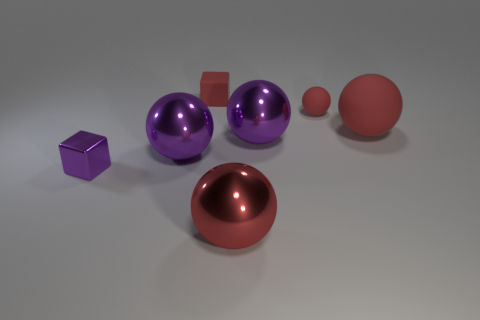There is a red thing that is the same shape as the small purple thing; what is its size?
Your answer should be very brief. Small. Do the red sphere that is in front of the large rubber sphere and the tiny block in front of the large red rubber thing have the same material?
Ensure brevity in your answer.  Yes. Is the number of large balls that are left of the metallic cube less than the number of big red balls?
Provide a short and direct response. Yes. Are there any other things that are the same shape as the tiny metal thing?
Offer a terse response. Yes. There is a matte thing that is the same shape as the tiny purple metallic object; what is its color?
Offer a terse response. Red. There is a purple sphere on the right side of the red shiny ball; is it the same size as the small metallic thing?
Make the answer very short. No. There is a purple ball on the left side of the purple object that is on the right side of the red block; what size is it?
Provide a short and direct response. Large. Is the tiny sphere made of the same material as the big ball on the left side of the red metal object?
Offer a terse response. No. Is the number of large red matte spheres that are in front of the small purple block less than the number of large purple things that are behind the red matte block?
Your answer should be very brief. No. What is the color of the tiny ball that is the same material as the small red block?
Ensure brevity in your answer.  Red. 